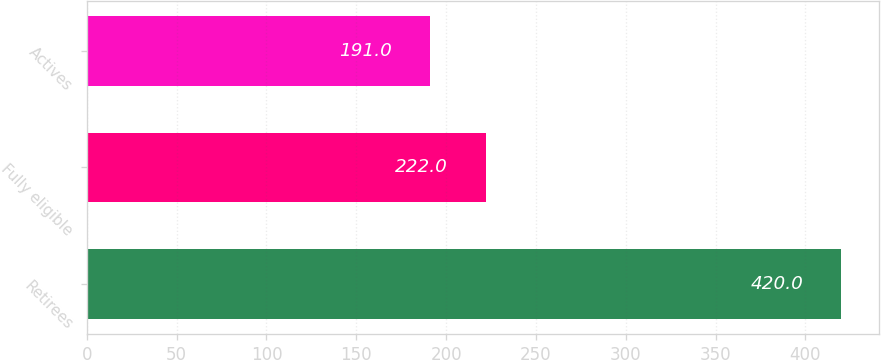Convert chart. <chart><loc_0><loc_0><loc_500><loc_500><bar_chart><fcel>Retirees<fcel>Fully eligible<fcel>Actives<nl><fcel>420<fcel>222<fcel>191<nl></chart> 